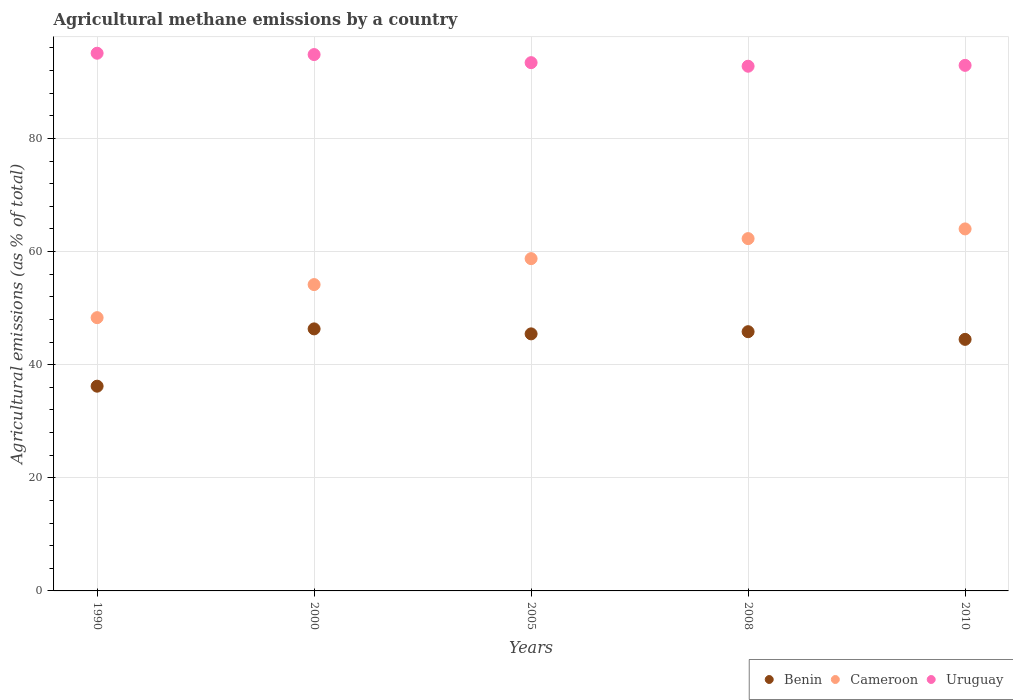Is the number of dotlines equal to the number of legend labels?
Give a very brief answer. Yes. What is the amount of agricultural methane emitted in Benin in 1990?
Keep it short and to the point. 36.19. Across all years, what is the maximum amount of agricultural methane emitted in Uruguay?
Provide a succinct answer. 95.06. Across all years, what is the minimum amount of agricultural methane emitted in Benin?
Your response must be concise. 36.19. What is the total amount of agricultural methane emitted in Cameroon in the graph?
Ensure brevity in your answer.  287.48. What is the difference between the amount of agricultural methane emitted in Cameroon in 2000 and that in 2010?
Keep it short and to the point. -9.84. What is the difference between the amount of agricultural methane emitted in Benin in 1990 and the amount of agricultural methane emitted in Uruguay in 2000?
Your answer should be very brief. -58.62. What is the average amount of agricultural methane emitted in Cameroon per year?
Give a very brief answer. 57.5. In the year 2008, what is the difference between the amount of agricultural methane emitted in Cameroon and amount of agricultural methane emitted in Benin?
Your response must be concise. 16.46. What is the ratio of the amount of agricultural methane emitted in Uruguay in 2000 to that in 2008?
Offer a terse response. 1.02. Is the difference between the amount of agricultural methane emitted in Cameroon in 2005 and 2010 greater than the difference between the amount of agricultural methane emitted in Benin in 2005 and 2010?
Make the answer very short. No. What is the difference between the highest and the second highest amount of agricultural methane emitted in Uruguay?
Your answer should be very brief. 0.24. What is the difference between the highest and the lowest amount of agricultural methane emitted in Benin?
Make the answer very short. 10.13. Is it the case that in every year, the sum of the amount of agricultural methane emitted in Benin and amount of agricultural methane emitted in Cameroon  is greater than the amount of agricultural methane emitted in Uruguay?
Offer a terse response. No. Does the amount of agricultural methane emitted in Benin monotonically increase over the years?
Offer a very short reply. No. Is the amount of agricultural methane emitted in Benin strictly greater than the amount of agricultural methane emitted in Uruguay over the years?
Provide a succinct answer. No. How many dotlines are there?
Your answer should be very brief. 3. Does the graph contain any zero values?
Your answer should be very brief. No. Where does the legend appear in the graph?
Ensure brevity in your answer.  Bottom right. How many legend labels are there?
Your answer should be very brief. 3. How are the legend labels stacked?
Provide a short and direct response. Horizontal. What is the title of the graph?
Make the answer very short. Agricultural methane emissions by a country. Does "Iceland" appear as one of the legend labels in the graph?
Provide a succinct answer. No. What is the label or title of the Y-axis?
Your response must be concise. Agricultural emissions (as % of total). What is the Agricultural emissions (as % of total) in Benin in 1990?
Offer a very short reply. 36.19. What is the Agricultural emissions (as % of total) in Cameroon in 1990?
Your answer should be very brief. 48.31. What is the Agricultural emissions (as % of total) in Uruguay in 1990?
Offer a terse response. 95.06. What is the Agricultural emissions (as % of total) in Benin in 2000?
Your answer should be very brief. 46.32. What is the Agricultural emissions (as % of total) of Cameroon in 2000?
Ensure brevity in your answer.  54.15. What is the Agricultural emissions (as % of total) of Uruguay in 2000?
Your answer should be very brief. 94.82. What is the Agricultural emissions (as % of total) in Benin in 2005?
Your answer should be compact. 45.44. What is the Agricultural emissions (as % of total) in Cameroon in 2005?
Provide a short and direct response. 58.74. What is the Agricultural emissions (as % of total) of Uruguay in 2005?
Your answer should be compact. 93.39. What is the Agricultural emissions (as % of total) of Benin in 2008?
Offer a very short reply. 45.83. What is the Agricultural emissions (as % of total) in Cameroon in 2008?
Your response must be concise. 62.28. What is the Agricultural emissions (as % of total) in Uruguay in 2008?
Make the answer very short. 92.76. What is the Agricultural emissions (as % of total) in Benin in 2010?
Keep it short and to the point. 44.47. What is the Agricultural emissions (as % of total) in Cameroon in 2010?
Ensure brevity in your answer.  64. What is the Agricultural emissions (as % of total) in Uruguay in 2010?
Keep it short and to the point. 92.91. Across all years, what is the maximum Agricultural emissions (as % of total) in Benin?
Offer a very short reply. 46.32. Across all years, what is the maximum Agricultural emissions (as % of total) of Cameroon?
Make the answer very short. 64. Across all years, what is the maximum Agricultural emissions (as % of total) of Uruguay?
Keep it short and to the point. 95.06. Across all years, what is the minimum Agricultural emissions (as % of total) in Benin?
Keep it short and to the point. 36.19. Across all years, what is the minimum Agricultural emissions (as % of total) in Cameroon?
Ensure brevity in your answer.  48.31. Across all years, what is the minimum Agricultural emissions (as % of total) in Uruguay?
Your response must be concise. 92.76. What is the total Agricultural emissions (as % of total) in Benin in the graph?
Provide a succinct answer. 218.26. What is the total Agricultural emissions (as % of total) in Cameroon in the graph?
Ensure brevity in your answer.  287.48. What is the total Agricultural emissions (as % of total) of Uruguay in the graph?
Offer a terse response. 468.93. What is the difference between the Agricultural emissions (as % of total) of Benin in 1990 and that in 2000?
Your answer should be very brief. -10.13. What is the difference between the Agricultural emissions (as % of total) of Cameroon in 1990 and that in 2000?
Offer a terse response. -5.85. What is the difference between the Agricultural emissions (as % of total) of Uruguay in 1990 and that in 2000?
Provide a short and direct response. 0.24. What is the difference between the Agricultural emissions (as % of total) in Benin in 1990 and that in 2005?
Offer a terse response. -9.25. What is the difference between the Agricultural emissions (as % of total) of Cameroon in 1990 and that in 2005?
Your answer should be very brief. -10.43. What is the difference between the Agricultural emissions (as % of total) in Uruguay in 1990 and that in 2005?
Ensure brevity in your answer.  1.67. What is the difference between the Agricultural emissions (as % of total) in Benin in 1990 and that in 2008?
Ensure brevity in your answer.  -9.63. What is the difference between the Agricultural emissions (as % of total) in Cameroon in 1990 and that in 2008?
Provide a short and direct response. -13.97. What is the difference between the Agricultural emissions (as % of total) of Uruguay in 1990 and that in 2008?
Provide a short and direct response. 2.3. What is the difference between the Agricultural emissions (as % of total) in Benin in 1990 and that in 2010?
Your answer should be very brief. -8.28. What is the difference between the Agricultural emissions (as % of total) in Cameroon in 1990 and that in 2010?
Give a very brief answer. -15.69. What is the difference between the Agricultural emissions (as % of total) of Uruguay in 1990 and that in 2010?
Ensure brevity in your answer.  2.15. What is the difference between the Agricultural emissions (as % of total) in Benin in 2000 and that in 2005?
Offer a terse response. 0.88. What is the difference between the Agricultural emissions (as % of total) of Cameroon in 2000 and that in 2005?
Provide a short and direct response. -4.59. What is the difference between the Agricultural emissions (as % of total) of Uruguay in 2000 and that in 2005?
Offer a very short reply. 1.43. What is the difference between the Agricultural emissions (as % of total) in Benin in 2000 and that in 2008?
Give a very brief answer. 0.5. What is the difference between the Agricultural emissions (as % of total) in Cameroon in 2000 and that in 2008?
Offer a terse response. -8.13. What is the difference between the Agricultural emissions (as % of total) in Uruguay in 2000 and that in 2008?
Offer a terse response. 2.06. What is the difference between the Agricultural emissions (as % of total) of Benin in 2000 and that in 2010?
Your response must be concise. 1.85. What is the difference between the Agricultural emissions (as % of total) in Cameroon in 2000 and that in 2010?
Make the answer very short. -9.84. What is the difference between the Agricultural emissions (as % of total) in Uruguay in 2000 and that in 2010?
Provide a short and direct response. 1.91. What is the difference between the Agricultural emissions (as % of total) in Benin in 2005 and that in 2008?
Make the answer very short. -0.38. What is the difference between the Agricultural emissions (as % of total) of Cameroon in 2005 and that in 2008?
Your answer should be compact. -3.54. What is the difference between the Agricultural emissions (as % of total) in Uruguay in 2005 and that in 2008?
Provide a short and direct response. 0.63. What is the difference between the Agricultural emissions (as % of total) in Benin in 2005 and that in 2010?
Your response must be concise. 0.97. What is the difference between the Agricultural emissions (as % of total) in Cameroon in 2005 and that in 2010?
Your answer should be very brief. -5.26. What is the difference between the Agricultural emissions (as % of total) of Uruguay in 2005 and that in 2010?
Your response must be concise. 0.48. What is the difference between the Agricultural emissions (as % of total) in Benin in 2008 and that in 2010?
Offer a terse response. 1.36. What is the difference between the Agricultural emissions (as % of total) of Cameroon in 2008 and that in 2010?
Provide a succinct answer. -1.71. What is the difference between the Agricultural emissions (as % of total) in Uruguay in 2008 and that in 2010?
Your response must be concise. -0.15. What is the difference between the Agricultural emissions (as % of total) in Benin in 1990 and the Agricultural emissions (as % of total) in Cameroon in 2000?
Ensure brevity in your answer.  -17.96. What is the difference between the Agricultural emissions (as % of total) in Benin in 1990 and the Agricultural emissions (as % of total) in Uruguay in 2000?
Keep it short and to the point. -58.62. What is the difference between the Agricultural emissions (as % of total) of Cameroon in 1990 and the Agricultural emissions (as % of total) of Uruguay in 2000?
Provide a short and direct response. -46.51. What is the difference between the Agricultural emissions (as % of total) in Benin in 1990 and the Agricultural emissions (as % of total) in Cameroon in 2005?
Give a very brief answer. -22.55. What is the difference between the Agricultural emissions (as % of total) of Benin in 1990 and the Agricultural emissions (as % of total) of Uruguay in 2005?
Provide a short and direct response. -57.19. What is the difference between the Agricultural emissions (as % of total) in Cameroon in 1990 and the Agricultural emissions (as % of total) in Uruguay in 2005?
Offer a terse response. -45.08. What is the difference between the Agricultural emissions (as % of total) in Benin in 1990 and the Agricultural emissions (as % of total) in Cameroon in 2008?
Keep it short and to the point. -26.09. What is the difference between the Agricultural emissions (as % of total) in Benin in 1990 and the Agricultural emissions (as % of total) in Uruguay in 2008?
Provide a short and direct response. -56.56. What is the difference between the Agricultural emissions (as % of total) in Cameroon in 1990 and the Agricultural emissions (as % of total) in Uruguay in 2008?
Provide a short and direct response. -44.45. What is the difference between the Agricultural emissions (as % of total) of Benin in 1990 and the Agricultural emissions (as % of total) of Cameroon in 2010?
Your response must be concise. -27.8. What is the difference between the Agricultural emissions (as % of total) of Benin in 1990 and the Agricultural emissions (as % of total) of Uruguay in 2010?
Provide a succinct answer. -56.72. What is the difference between the Agricultural emissions (as % of total) in Cameroon in 1990 and the Agricultural emissions (as % of total) in Uruguay in 2010?
Provide a succinct answer. -44.6. What is the difference between the Agricultural emissions (as % of total) in Benin in 2000 and the Agricultural emissions (as % of total) in Cameroon in 2005?
Make the answer very short. -12.42. What is the difference between the Agricultural emissions (as % of total) in Benin in 2000 and the Agricultural emissions (as % of total) in Uruguay in 2005?
Provide a short and direct response. -47.07. What is the difference between the Agricultural emissions (as % of total) of Cameroon in 2000 and the Agricultural emissions (as % of total) of Uruguay in 2005?
Provide a succinct answer. -39.23. What is the difference between the Agricultural emissions (as % of total) of Benin in 2000 and the Agricultural emissions (as % of total) of Cameroon in 2008?
Make the answer very short. -15.96. What is the difference between the Agricultural emissions (as % of total) of Benin in 2000 and the Agricultural emissions (as % of total) of Uruguay in 2008?
Provide a succinct answer. -46.43. What is the difference between the Agricultural emissions (as % of total) in Cameroon in 2000 and the Agricultural emissions (as % of total) in Uruguay in 2008?
Offer a terse response. -38.6. What is the difference between the Agricultural emissions (as % of total) in Benin in 2000 and the Agricultural emissions (as % of total) in Cameroon in 2010?
Ensure brevity in your answer.  -17.67. What is the difference between the Agricultural emissions (as % of total) in Benin in 2000 and the Agricultural emissions (as % of total) in Uruguay in 2010?
Ensure brevity in your answer.  -46.59. What is the difference between the Agricultural emissions (as % of total) in Cameroon in 2000 and the Agricultural emissions (as % of total) in Uruguay in 2010?
Your answer should be very brief. -38.76. What is the difference between the Agricultural emissions (as % of total) in Benin in 2005 and the Agricultural emissions (as % of total) in Cameroon in 2008?
Your answer should be compact. -16.84. What is the difference between the Agricultural emissions (as % of total) of Benin in 2005 and the Agricultural emissions (as % of total) of Uruguay in 2008?
Provide a succinct answer. -47.31. What is the difference between the Agricultural emissions (as % of total) in Cameroon in 2005 and the Agricultural emissions (as % of total) in Uruguay in 2008?
Your response must be concise. -34.02. What is the difference between the Agricultural emissions (as % of total) of Benin in 2005 and the Agricultural emissions (as % of total) of Cameroon in 2010?
Offer a terse response. -18.55. What is the difference between the Agricultural emissions (as % of total) in Benin in 2005 and the Agricultural emissions (as % of total) in Uruguay in 2010?
Offer a terse response. -47.47. What is the difference between the Agricultural emissions (as % of total) of Cameroon in 2005 and the Agricultural emissions (as % of total) of Uruguay in 2010?
Make the answer very short. -34.17. What is the difference between the Agricultural emissions (as % of total) of Benin in 2008 and the Agricultural emissions (as % of total) of Cameroon in 2010?
Ensure brevity in your answer.  -18.17. What is the difference between the Agricultural emissions (as % of total) of Benin in 2008 and the Agricultural emissions (as % of total) of Uruguay in 2010?
Your answer should be very brief. -47.08. What is the difference between the Agricultural emissions (as % of total) of Cameroon in 2008 and the Agricultural emissions (as % of total) of Uruguay in 2010?
Keep it short and to the point. -30.63. What is the average Agricultural emissions (as % of total) in Benin per year?
Keep it short and to the point. 43.65. What is the average Agricultural emissions (as % of total) of Cameroon per year?
Offer a very short reply. 57.5. What is the average Agricultural emissions (as % of total) of Uruguay per year?
Provide a short and direct response. 93.79. In the year 1990, what is the difference between the Agricultural emissions (as % of total) of Benin and Agricultural emissions (as % of total) of Cameroon?
Offer a terse response. -12.11. In the year 1990, what is the difference between the Agricultural emissions (as % of total) of Benin and Agricultural emissions (as % of total) of Uruguay?
Provide a succinct answer. -58.86. In the year 1990, what is the difference between the Agricultural emissions (as % of total) of Cameroon and Agricultural emissions (as % of total) of Uruguay?
Keep it short and to the point. -46.75. In the year 2000, what is the difference between the Agricultural emissions (as % of total) of Benin and Agricultural emissions (as % of total) of Cameroon?
Offer a terse response. -7.83. In the year 2000, what is the difference between the Agricultural emissions (as % of total) of Benin and Agricultural emissions (as % of total) of Uruguay?
Make the answer very short. -48.5. In the year 2000, what is the difference between the Agricultural emissions (as % of total) of Cameroon and Agricultural emissions (as % of total) of Uruguay?
Provide a short and direct response. -40.66. In the year 2005, what is the difference between the Agricultural emissions (as % of total) of Benin and Agricultural emissions (as % of total) of Cameroon?
Give a very brief answer. -13.3. In the year 2005, what is the difference between the Agricultural emissions (as % of total) in Benin and Agricultural emissions (as % of total) in Uruguay?
Give a very brief answer. -47.95. In the year 2005, what is the difference between the Agricultural emissions (as % of total) in Cameroon and Agricultural emissions (as % of total) in Uruguay?
Your answer should be compact. -34.65. In the year 2008, what is the difference between the Agricultural emissions (as % of total) of Benin and Agricultural emissions (as % of total) of Cameroon?
Ensure brevity in your answer.  -16.46. In the year 2008, what is the difference between the Agricultural emissions (as % of total) in Benin and Agricultural emissions (as % of total) in Uruguay?
Offer a terse response. -46.93. In the year 2008, what is the difference between the Agricultural emissions (as % of total) of Cameroon and Agricultural emissions (as % of total) of Uruguay?
Offer a terse response. -30.47. In the year 2010, what is the difference between the Agricultural emissions (as % of total) in Benin and Agricultural emissions (as % of total) in Cameroon?
Offer a very short reply. -19.53. In the year 2010, what is the difference between the Agricultural emissions (as % of total) in Benin and Agricultural emissions (as % of total) in Uruguay?
Give a very brief answer. -48.44. In the year 2010, what is the difference between the Agricultural emissions (as % of total) in Cameroon and Agricultural emissions (as % of total) in Uruguay?
Make the answer very short. -28.91. What is the ratio of the Agricultural emissions (as % of total) of Benin in 1990 to that in 2000?
Keep it short and to the point. 0.78. What is the ratio of the Agricultural emissions (as % of total) of Cameroon in 1990 to that in 2000?
Your answer should be very brief. 0.89. What is the ratio of the Agricultural emissions (as % of total) in Uruguay in 1990 to that in 2000?
Give a very brief answer. 1. What is the ratio of the Agricultural emissions (as % of total) in Benin in 1990 to that in 2005?
Give a very brief answer. 0.8. What is the ratio of the Agricultural emissions (as % of total) in Cameroon in 1990 to that in 2005?
Give a very brief answer. 0.82. What is the ratio of the Agricultural emissions (as % of total) in Uruguay in 1990 to that in 2005?
Offer a very short reply. 1.02. What is the ratio of the Agricultural emissions (as % of total) in Benin in 1990 to that in 2008?
Your answer should be compact. 0.79. What is the ratio of the Agricultural emissions (as % of total) of Cameroon in 1990 to that in 2008?
Provide a succinct answer. 0.78. What is the ratio of the Agricultural emissions (as % of total) of Uruguay in 1990 to that in 2008?
Offer a very short reply. 1.02. What is the ratio of the Agricultural emissions (as % of total) of Benin in 1990 to that in 2010?
Your answer should be very brief. 0.81. What is the ratio of the Agricultural emissions (as % of total) in Cameroon in 1990 to that in 2010?
Provide a succinct answer. 0.75. What is the ratio of the Agricultural emissions (as % of total) in Uruguay in 1990 to that in 2010?
Keep it short and to the point. 1.02. What is the ratio of the Agricultural emissions (as % of total) in Benin in 2000 to that in 2005?
Your answer should be very brief. 1.02. What is the ratio of the Agricultural emissions (as % of total) of Cameroon in 2000 to that in 2005?
Keep it short and to the point. 0.92. What is the ratio of the Agricultural emissions (as % of total) of Uruguay in 2000 to that in 2005?
Offer a terse response. 1.02. What is the ratio of the Agricultural emissions (as % of total) of Benin in 2000 to that in 2008?
Ensure brevity in your answer.  1.01. What is the ratio of the Agricultural emissions (as % of total) in Cameroon in 2000 to that in 2008?
Your answer should be compact. 0.87. What is the ratio of the Agricultural emissions (as % of total) of Uruguay in 2000 to that in 2008?
Your answer should be compact. 1.02. What is the ratio of the Agricultural emissions (as % of total) in Benin in 2000 to that in 2010?
Ensure brevity in your answer.  1.04. What is the ratio of the Agricultural emissions (as % of total) in Cameroon in 2000 to that in 2010?
Your answer should be very brief. 0.85. What is the ratio of the Agricultural emissions (as % of total) of Uruguay in 2000 to that in 2010?
Give a very brief answer. 1.02. What is the ratio of the Agricultural emissions (as % of total) in Benin in 2005 to that in 2008?
Provide a succinct answer. 0.99. What is the ratio of the Agricultural emissions (as % of total) in Cameroon in 2005 to that in 2008?
Your response must be concise. 0.94. What is the ratio of the Agricultural emissions (as % of total) of Uruguay in 2005 to that in 2008?
Offer a terse response. 1.01. What is the ratio of the Agricultural emissions (as % of total) in Benin in 2005 to that in 2010?
Your answer should be compact. 1.02. What is the ratio of the Agricultural emissions (as % of total) in Cameroon in 2005 to that in 2010?
Offer a terse response. 0.92. What is the ratio of the Agricultural emissions (as % of total) in Uruguay in 2005 to that in 2010?
Provide a short and direct response. 1.01. What is the ratio of the Agricultural emissions (as % of total) of Benin in 2008 to that in 2010?
Offer a terse response. 1.03. What is the ratio of the Agricultural emissions (as % of total) of Cameroon in 2008 to that in 2010?
Provide a short and direct response. 0.97. What is the difference between the highest and the second highest Agricultural emissions (as % of total) in Benin?
Ensure brevity in your answer.  0.5. What is the difference between the highest and the second highest Agricultural emissions (as % of total) of Cameroon?
Your answer should be compact. 1.71. What is the difference between the highest and the second highest Agricultural emissions (as % of total) of Uruguay?
Offer a terse response. 0.24. What is the difference between the highest and the lowest Agricultural emissions (as % of total) of Benin?
Your response must be concise. 10.13. What is the difference between the highest and the lowest Agricultural emissions (as % of total) of Cameroon?
Provide a short and direct response. 15.69. What is the difference between the highest and the lowest Agricultural emissions (as % of total) in Uruguay?
Offer a very short reply. 2.3. 